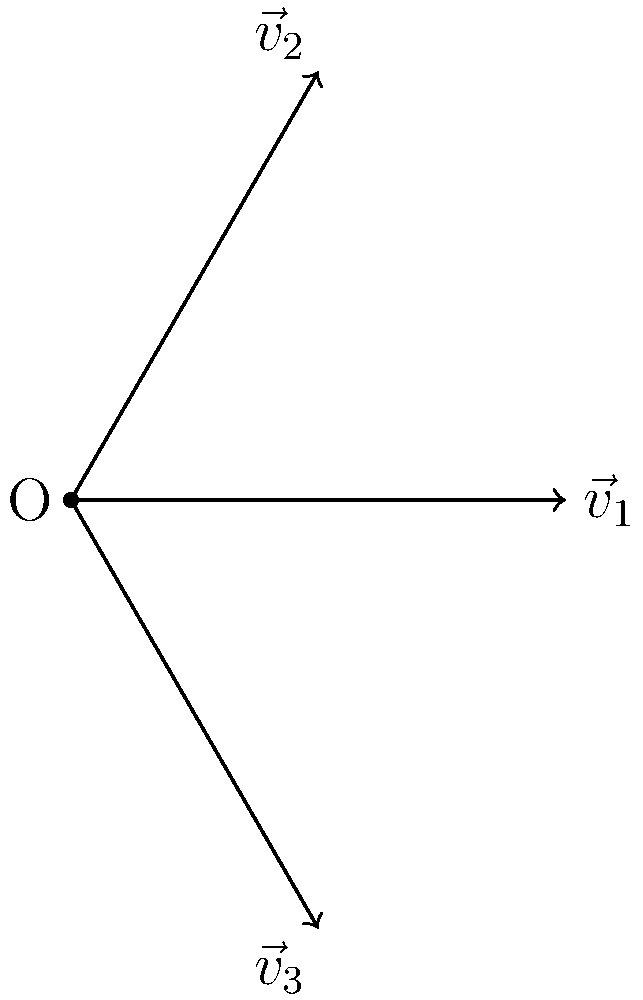In your recent integration with the Google Translate API, you're working on a feature to determine semantic similarity across languages using word embeddings. Given three word embedding vectors $\vec{v}_1$, $\vec{v}_2$, and $\vec{v}_3$ as shown in the diagram, where $\vec{v}_1 = (1, 0)$, $\vec{v}_2 = (0.5, 0.866)$, and $\vec{v}_3 = (0.5, -0.866)$, which pair of vectors represents the most semantically similar words across different languages? To determine the semantic similarity between word embedding vectors, we can use the dot product. The higher the dot product, the more similar the words are. Let's calculate the dot product for each pair:

1. For $\vec{v}_1$ and $\vec{v}_2$:
   $$\vec{v}_1 \cdot \vec{v}_2 = (1)(0.5) + (0)(0.866) = 0.5$$

2. For $\vec{v}_1$ and $\vec{v}_3$:
   $$\vec{v}_1 \cdot \vec{v}_3 = (1)(0.5) + (0)(-0.866) = 0.5$$

3. For $\vec{v}_2$ and $\vec{v}_3$:
   $$\vec{v}_2 \cdot \vec{v}_3 = (0.5)(0.5) + (0.866)(-0.866) = -0.5$$

The dot product between $\vec{v}_1$ and $\vec{v}_2$, and between $\vec{v}_1$ and $\vec{v}_3$ are both 0.5, which is higher than the dot product between $\vec{v}_2$ and $\vec{v}_3$ (-0.5).

Therefore, $\vec{v}_1$ is equally similar to both $\vec{v}_2$ and $\vec{v}_3$. However, $\vec{v}_2$ and $\vec{v}_3$ are the least similar pair.
Answer: $\vec{v}_1$ and $\vec{v}_2$, or $\vec{v}_1$ and $\vec{v}_3$ 